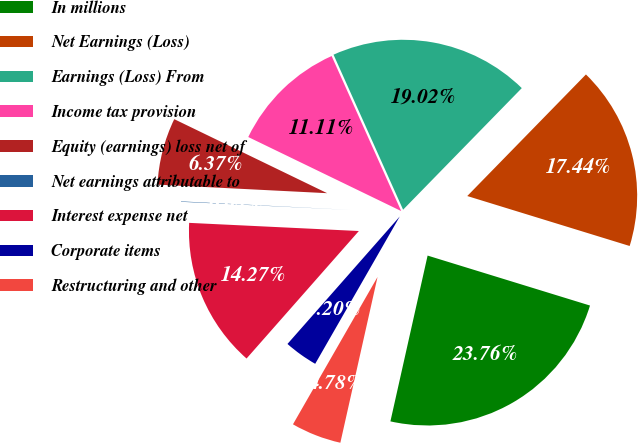<chart> <loc_0><loc_0><loc_500><loc_500><pie_chart><fcel>In millions<fcel>Net Earnings (Loss)<fcel>Earnings (Loss) From<fcel>Income tax provision<fcel>Equity (earnings) loss net of<fcel>Net earnings attributable to<fcel>Interest expense net<fcel>Corporate items<fcel>Restructuring and other<nl><fcel>23.76%<fcel>17.44%<fcel>19.02%<fcel>11.11%<fcel>6.37%<fcel>0.04%<fcel>14.27%<fcel>3.2%<fcel>4.78%<nl></chart> 